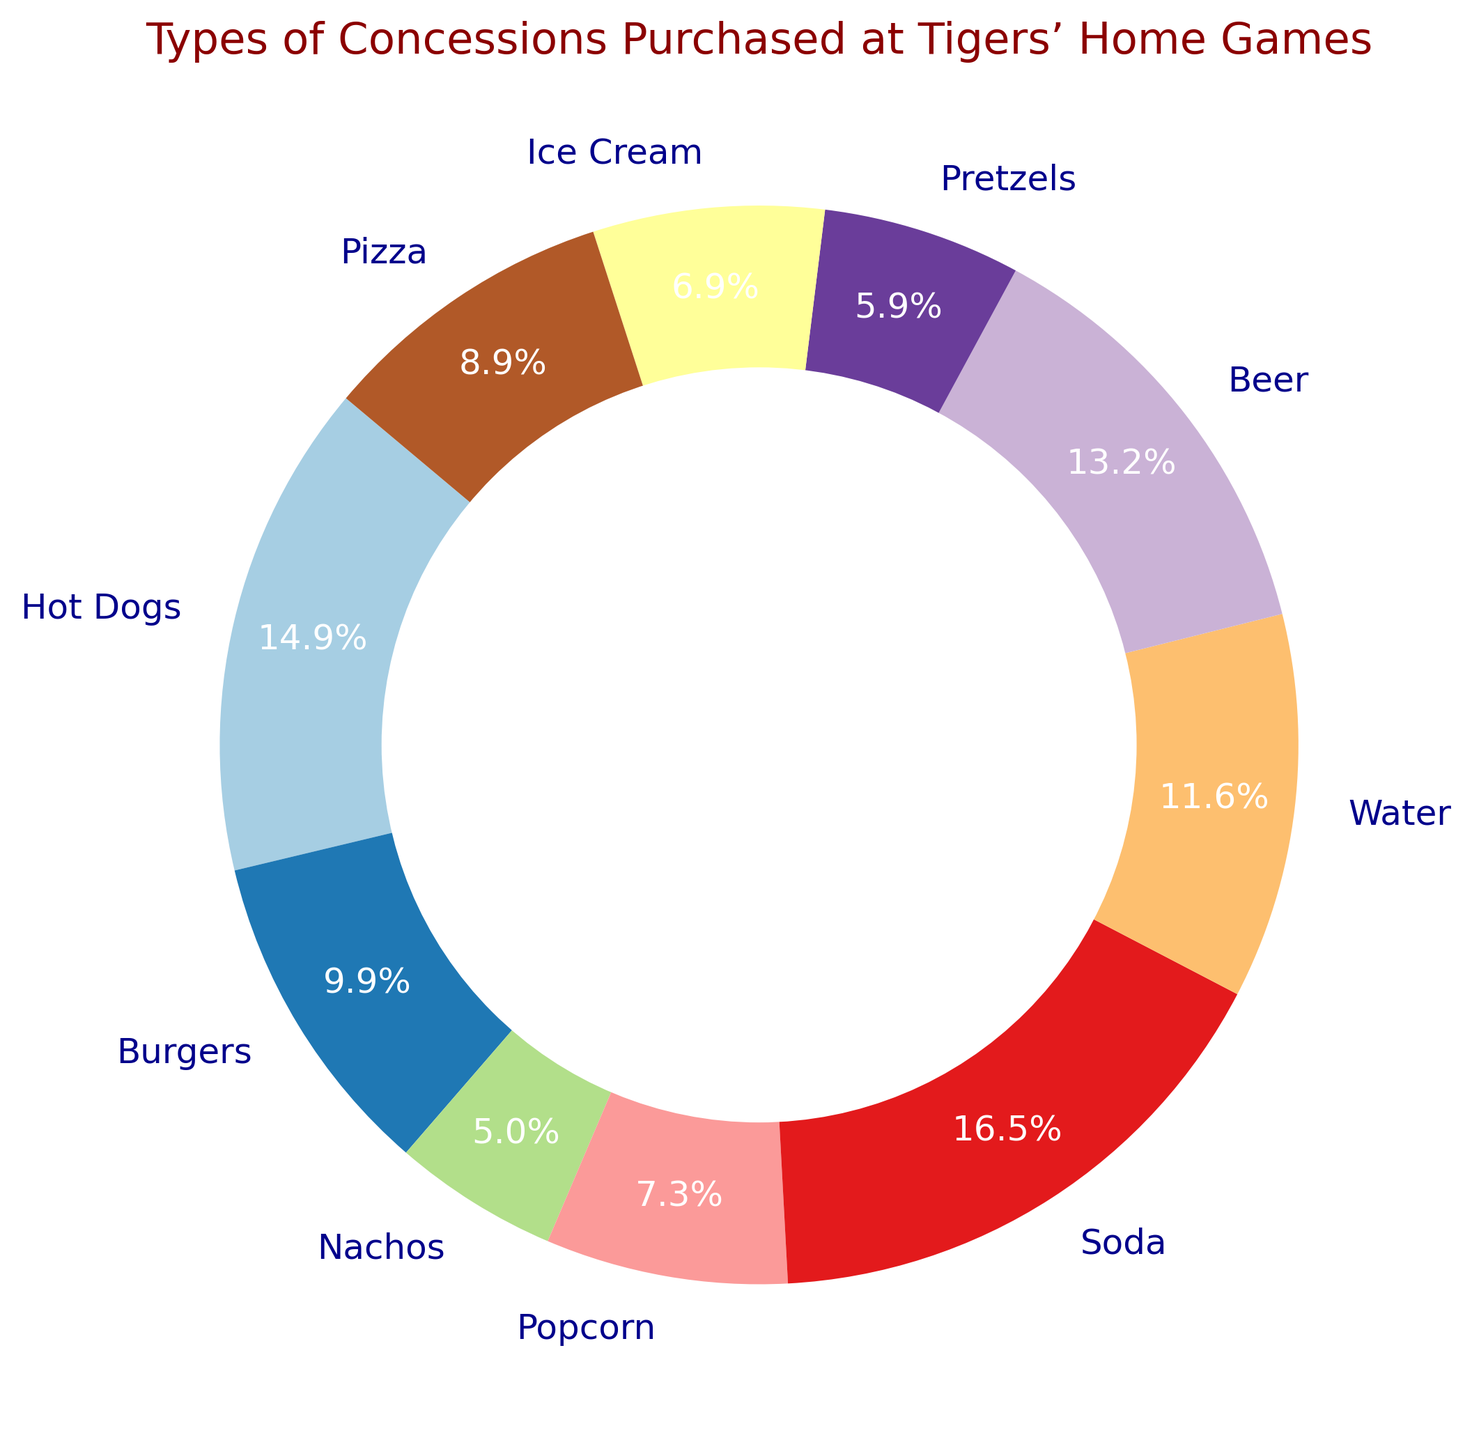What is the most purchased type of concession? By examining the pie chart, we see that the largest segment, representing 27.8%, corresponds to Soda, making it the most purchased type of concession.
Answer: Soda How many more Hot Dogs were purchased compared to Nachos? The chart shows that Hot Dogs and Nachos account for 25.0% and 8.3% of the sales respectively. Hot Dogs (450) - Nachos (150) = 300 more Hot Dogs were sold than Nachos.
Answer: 300 Which types of concessions have less than 10% share each? By looking at the segment percentages in the pie chart, Nachos, Pretzels, and Ice Cream each have less than 10% share, specifically 8.3%, 10%, and 9.7%, respectively.
Answer: Nachos, Pretzels, and Ice Cream What is the combined percentage of Burgers, Pizza, and Beer purchased? Adding the percentages for Burgers (16.7%), Pizza (15.0%), and Beer (22.2%) gives a combined percentage of 16.7% + 15.0% + 22.2% = 53.9%.
Answer: 53.9% Are more Sodas or Beers sold, and by how much? From the chart, Sodas account for 27.8% (500 units) and Beer account for 22.2% (400 units). Thus, more Sodas are sold than Beers by a margin of 500 - 400 = 100 units.
Answer: Sodas by 100 units Which type of concession represents roughly one-fourth of the sales? The pie chart indicates that Hot Dogs account for 25.0% of the sales, which is roughly one-fourth of the total sales.
Answer: Hot Dogs What type of concession has the smallest share, and what is its percentage? The smallest segment in the pie chart represents Nachos, with a share of 8.3%.
Answer: Nachos, 8.3% How many types of concessions have a share between 10% and 15%? By observing the chart, Popcorn (12.2%), Water (19.4%), and Pizza (15.0%) fall within the 10%-15% range. It turns out there are two, Popcorn and Pizza.
Answer: Two What is the difference in amount sold between Burgers and Water? The chart shows Burgers at 300 units and Water at 350 units, so the difference is 350 - 300 = 50 units more for Water.
Answer: 50 units more for Water Which types of concessions hold the same share percentage? Looking closer, none of the segments on the pie chart share the exact same percentage, indicating that each type of concession has a unique share.
Answer: None 